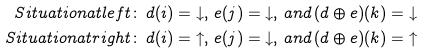<formula> <loc_0><loc_0><loc_500><loc_500>S i t u a t i o n a t l e f t \colon & \, d ( i ) = { \downarrow } , \, e ( j ) = { \downarrow } , \, a n d \, ( d \oplus e ) ( k ) = { \downarrow } \\ S i t u a t i o n a t r i g h t \colon & \, d ( i ) = { \uparrow } , \, e ( j ) = { \downarrow } , \, a n d \, ( d \oplus e ) ( k ) = { \uparrow }</formula> 